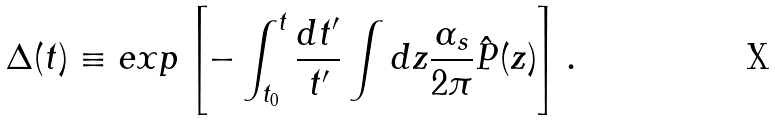<formula> <loc_0><loc_0><loc_500><loc_500>\Delta ( t ) \equiv e x p \left [ - \int _ { t _ { 0 } } ^ { t } \frac { d t ^ { \prime } } { t ^ { \prime } } \int d z \frac { \alpha _ { s } } { 2 \pi } \hat { P } ( z ) \right ] .</formula> 